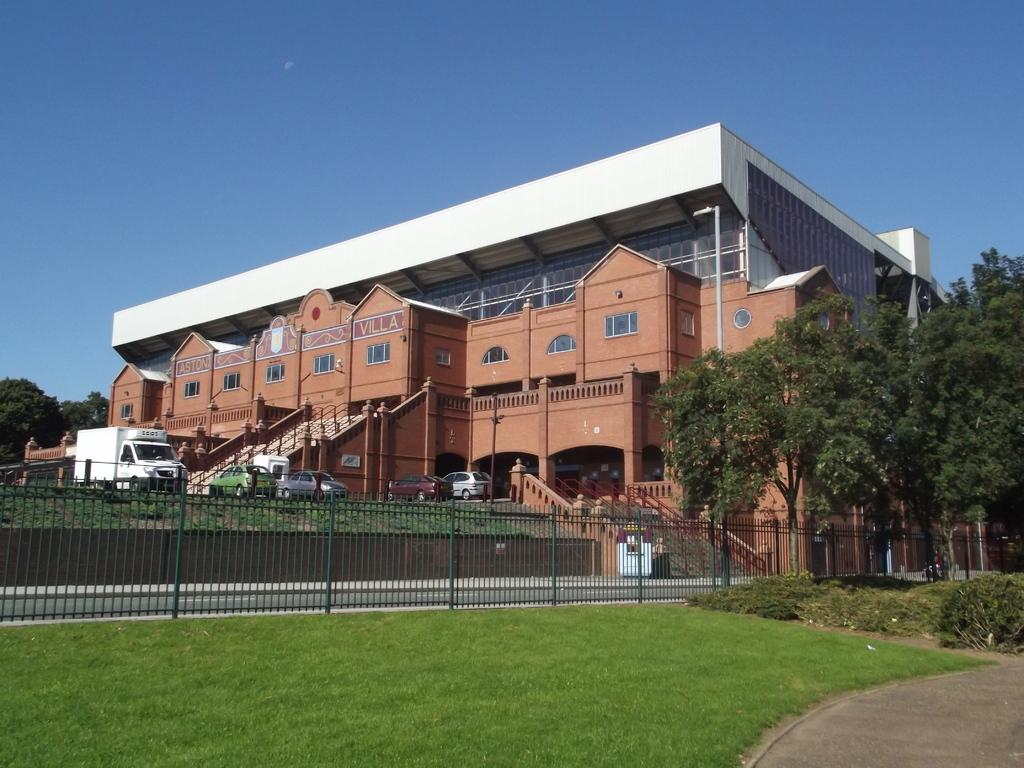What type of structure can be seen in the image? There is a railing in the image. What else is present in the image besides the railing? There are vehicles and trees with green color in the image. Can you describe the building in the image? The building in the image has a brown color. What is the color of the sky in the image? The sky is blue in the image. Where are the cherries hanging from in the image? There are no cherries present in the image. What type of bird can be seen sitting on the railing in the image? There is no bird, specifically a crow, present in the image. 